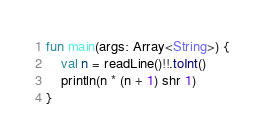<code> <loc_0><loc_0><loc_500><loc_500><_Kotlin_>fun main(args: Array<String>) {
    val n = readLine()!!.toInt()
    println(n * (n + 1) shr 1)
}
</code> 